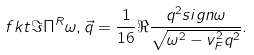<formula> <loc_0><loc_0><loc_500><loc_500>\ f k t { \Im \Pi ^ { R } } { \omega , \vec { q } } = \frac { 1 } { 1 6 } \Re \frac { q ^ { 2 } s i g n \omega } { \sqrt { \omega ^ { 2 } - v _ { F } ^ { 2 } q ^ { 2 } } } .</formula> 